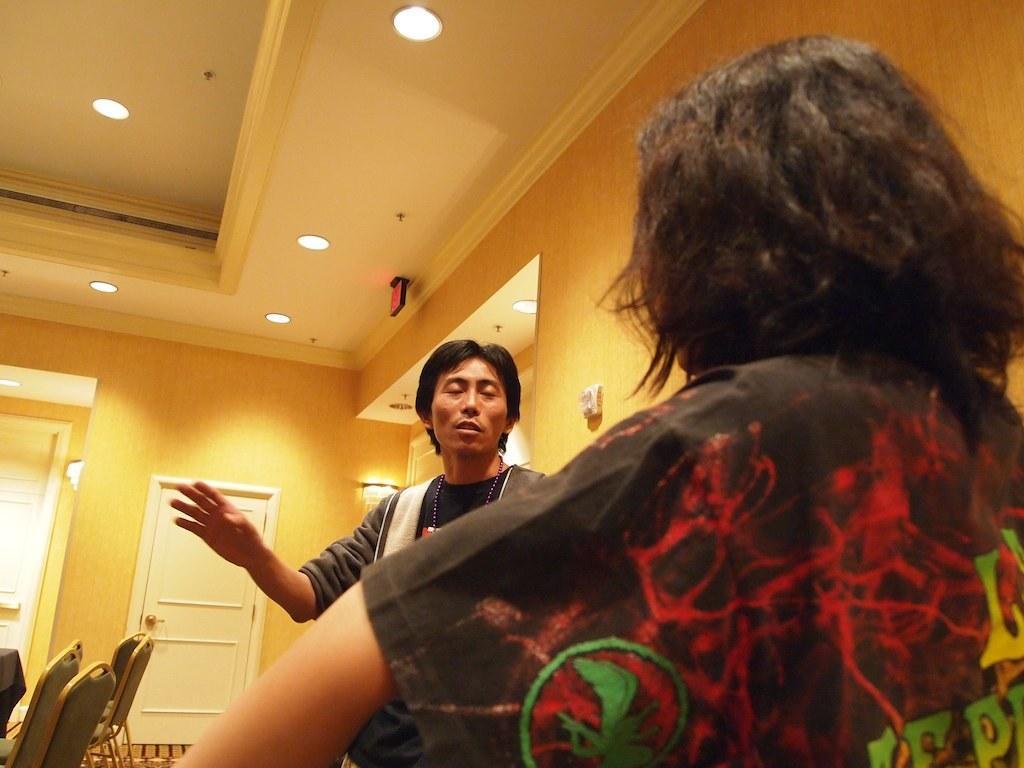Could you give a brief overview of what you see in this image? This image is clicked in a room. On the top there are lights. There are doors too. There is a person standing in the middle of the room and there is a woman on the right side. There are chairs on the bottom left side corner. The person who is standing is wearing a black jacket and he is also wearing a chain. Woman is wearing a black shirt. 